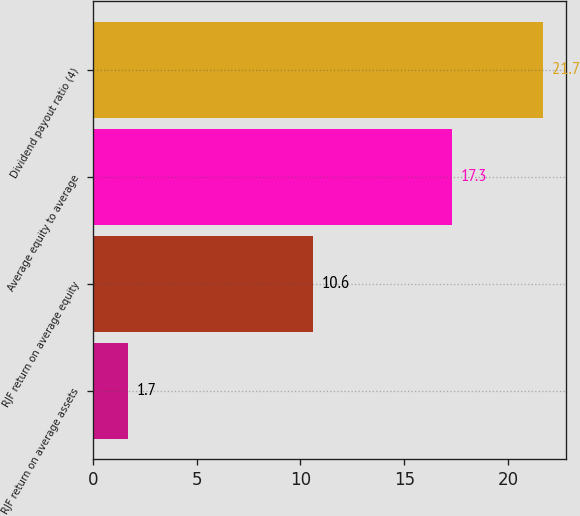<chart> <loc_0><loc_0><loc_500><loc_500><bar_chart><fcel>RJF return on average assets<fcel>RJF return on average equity<fcel>Average equity to average<fcel>Dividend payout ratio (4)<nl><fcel>1.7<fcel>10.6<fcel>17.3<fcel>21.7<nl></chart> 